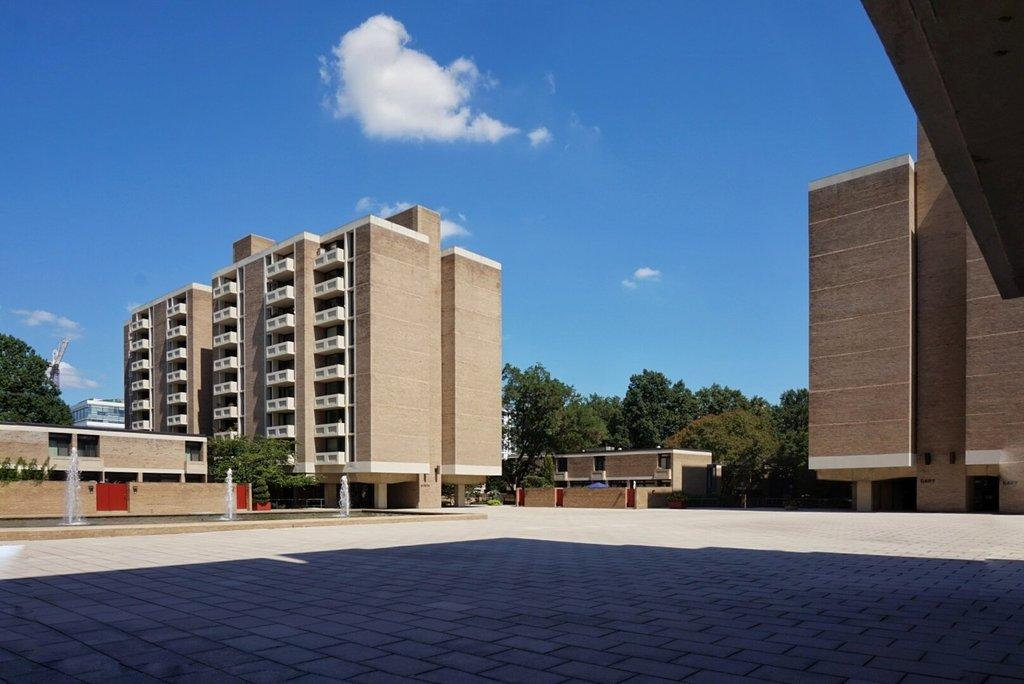What type of structures can be seen in the image? There are buildings in the image. What other natural elements are present in the image? There are trees in the image. Can you describe any specific features of the buildings? There are windows visible in the image. What can be seen in the water in the image? The water is visible in the image, but no specific details can be discerned from the provided facts. What is visible in the background of the image? The sky is visible in the background of the image, and there are clouds in the sky. What type of celery is being used to frame the buildings in the image? There is no celery present in the image, and it is not being used to frame the buildings. 